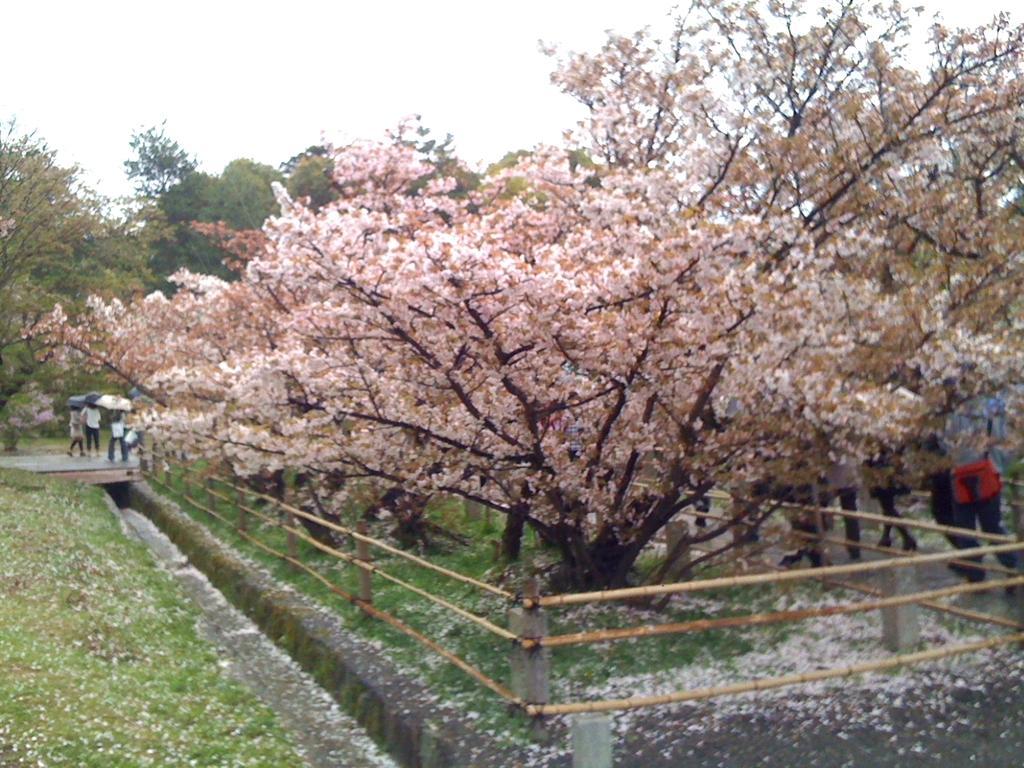How would you summarize this image in a sentence or two? In this image I can see some grass on the ground, the railing, few trees which are green, cream, pink and black in color and few persons standing and few of them are holding umbrellas. In the background I can see the sky. 